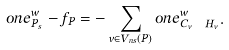Convert formula to latex. <formula><loc_0><loc_0><loc_500><loc_500>o n e ^ { w } _ { P _ { s } } - f _ { P } = - \sum _ { v \in V _ { n s } ( P ) } o n e ^ { w } _ { C _ { v } \ H _ { v } } .</formula> 